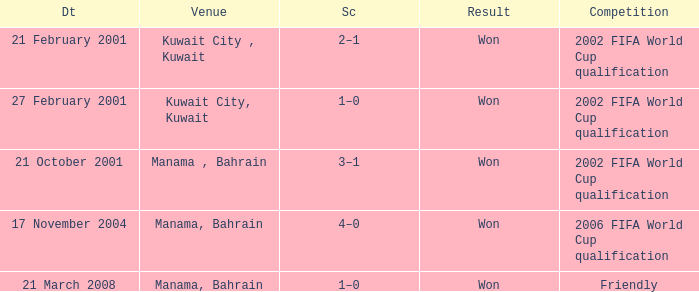What was the final score of the Friendly Competition in Manama, Bahrain? 1–0. 